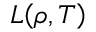Convert formula to latex. <formula><loc_0><loc_0><loc_500><loc_500>L \, \left ( \rho , T \right )</formula> 